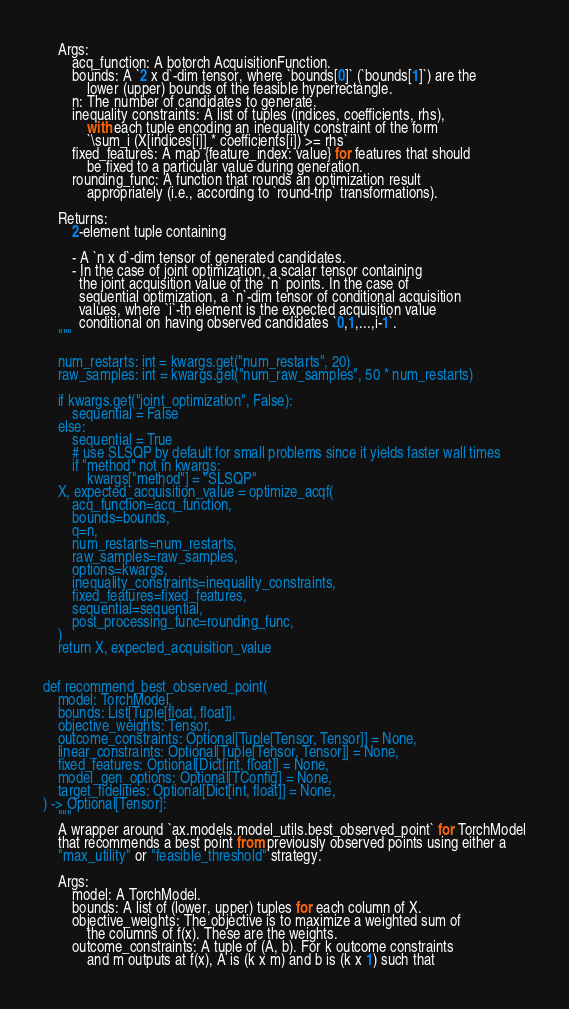<code> <loc_0><loc_0><loc_500><loc_500><_Python_>    Args:
        acq_function: A botorch AcquisitionFunction.
        bounds: A `2 x d`-dim tensor, where `bounds[0]` (`bounds[1]`) are the
            lower (upper) bounds of the feasible hyperrectangle.
        n: The number of candidates to generate.
        inequality constraints: A list of tuples (indices, coefficients, rhs),
            with each tuple encoding an inequality constraint of the form
            `\sum_i (X[indices[i]] * coefficients[i]) >= rhs`
        fixed_features: A map {feature_index: value} for features that should
            be fixed to a particular value during generation.
        rounding_func: A function that rounds an optimization result
            appropriately (i.e., according to `round-trip` transformations).

    Returns:
        2-element tuple containing

        - A `n x d`-dim tensor of generated candidates.
        - In the case of joint optimization, a scalar tensor containing
          the joint acquisition value of the `n` points. In the case of
          sequential optimization, a `n`-dim tensor of conditional acquisition
          values, where `i`-th element is the expected acquisition value
          conditional on having observed candidates `0,1,...,i-1`.
    """

    num_restarts: int = kwargs.get("num_restarts", 20)
    raw_samples: int = kwargs.get("num_raw_samples", 50 * num_restarts)

    if kwargs.get("joint_optimization", False):
        sequential = False
    else:
        sequential = True
        # use SLSQP by default for small problems since it yields faster wall times
        if "method" not in kwargs:
            kwargs["method"] = "SLSQP"
    X, expected_acquisition_value = optimize_acqf(
        acq_function=acq_function,
        bounds=bounds,
        q=n,
        num_restarts=num_restarts,
        raw_samples=raw_samples,
        options=kwargs,
        inequality_constraints=inequality_constraints,
        fixed_features=fixed_features,
        sequential=sequential,
        post_processing_func=rounding_func,
    )
    return X, expected_acquisition_value


def recommend_best_observed_point(
    model: TorchModel,
    bounds: List[Tuple[float, float]],
    objective_weights: Tensor,
    outcome_constraints: Optional[Tuple[Tensor, Tensor]] = None,
    linear_constraints: Optional[Tuple[Tensor, Tensor]] = None,
    fixed_features: Optional[Dict[int, float]] = None,
    model_gen_options: Optional[TConfig] = None,
    target_fidelities: Optional[Dict[int, float]] = None,
) -> Optional[Tensor]:
    """
    A wrapper around `ax.models.model_utils.best_observed_point` for TorchModel
    that recommends a best point from previously observed points using either a
    "max_utility" or "feasible_threshold" strategy.

    Args:
        model: A TorchModel.
        bounds: A list of (lower, upper) tuples for each column of X.
        objective_weights: The objective is to maximize a weighted sum of
            the columns of f(x). These are the weights.
        outcome_constraints: A tuple of (A, b). For k outcome constraints
            and m outputs at f(x), A is (k x m) and b is (k x 1) such that</code> 